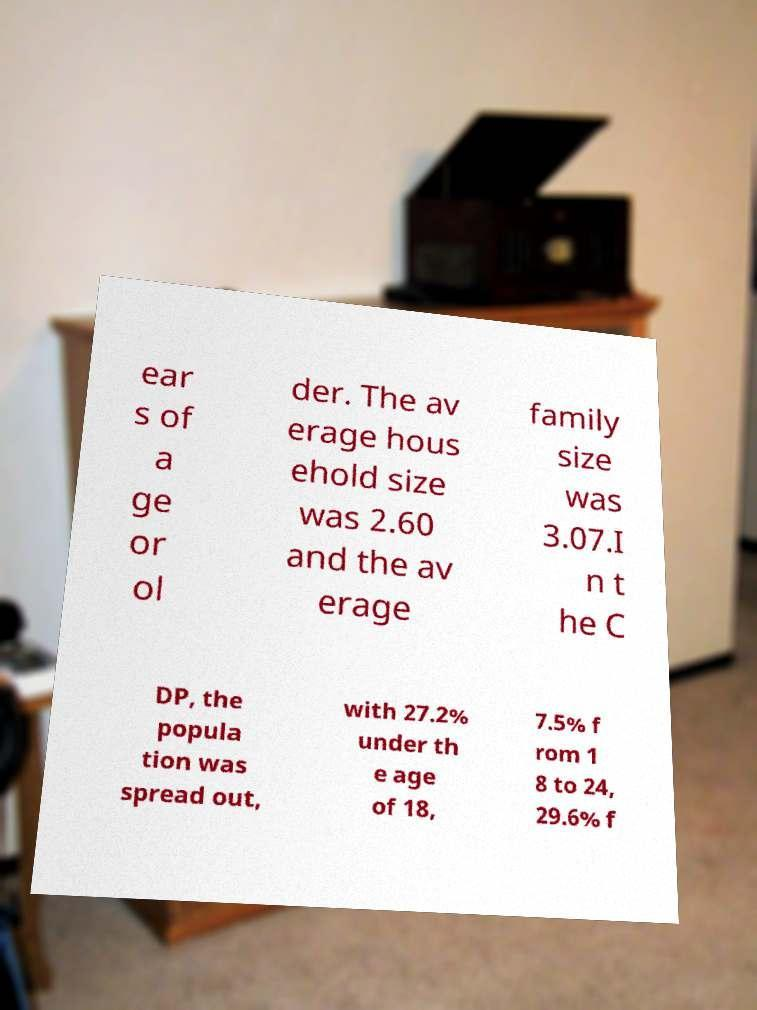There's text embedded in this image that I need extracted. Can you transcribe it verbatim? ear s of a ge or ol der. The av erage hous ehold size was 2.60 and the av erage family size was 3.07.I n t he C DP, the popula tion was spread out, with 27.2% under th e age of 18, 7.5% f rom 1 8 to 24, 29.6% f 